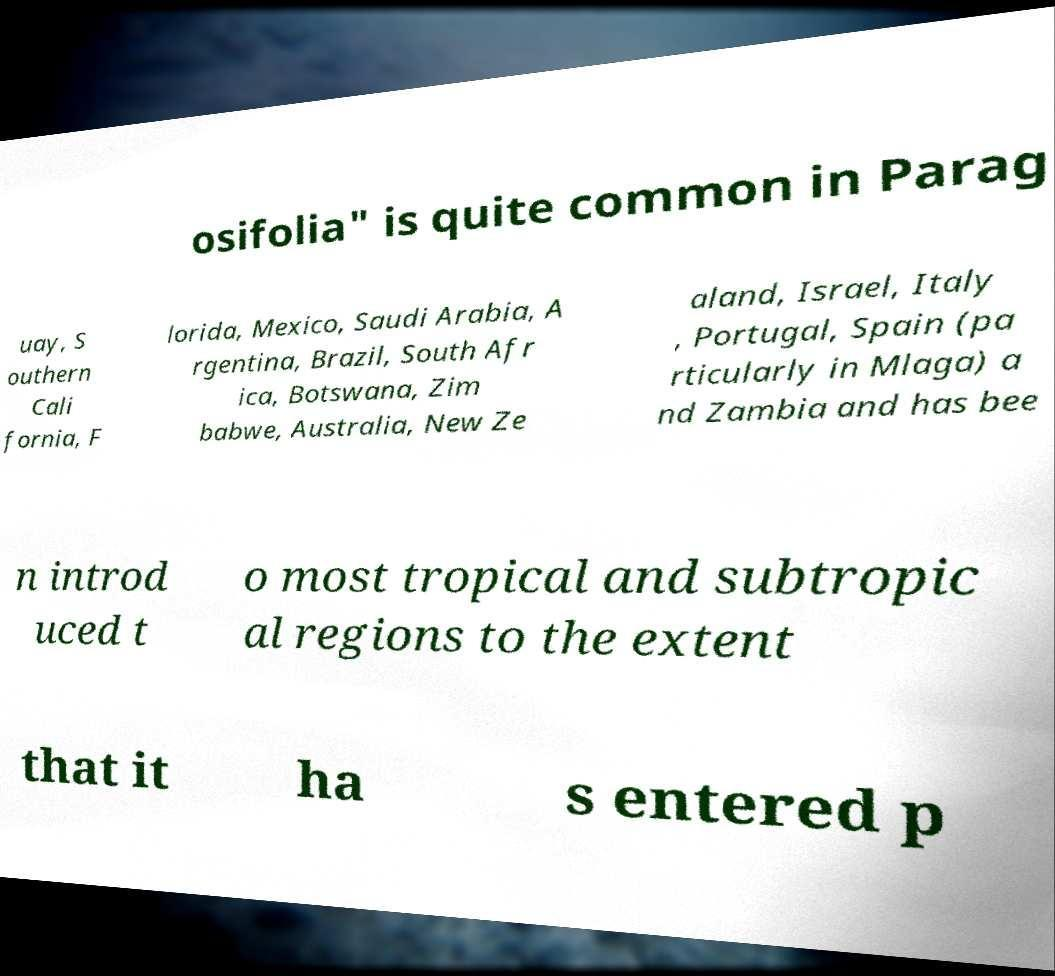For documentation purposes, I need the text within this image transcribed. Could you provide that? osifolia" is quite common in Parag uay, S outhern Cali fornia, F lorida, Mexico, Saudi Arabia, A rgentina, Brazil, South Afr ica, Botswana, Zim babwe, Australia, New Ze aland, Israel, Italy , Portugal, Spain (pa rticularly in Mlaga) a nd Zambia and has bee n introd uced t o most tropical and subtropic al regions to the extent that it ha s entered p 